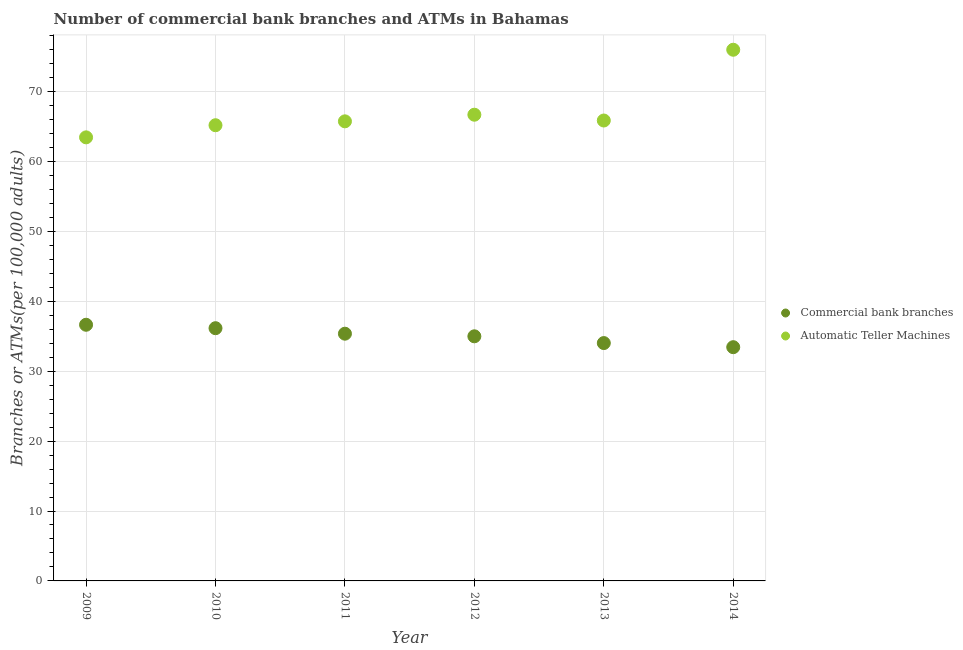How many different coloured dotlines are there?
Keep it short and to the point. 2. What is the number of atms in 2009?
Offer a terse response. 63.44. Across all years, what is the maximum number of commercal bank branches?
Provide a short and direct response. 36.64. Across all years, what is the minimum number of commercal bank branches?
Your answer should be very brief. 33.43. In which year was the number of atms minimum?
Ensure brevity in your answer.  2009. What is the total number of commercal bank branches in the graph?
Provide a short and direct response. 210.58. What is the difference between the number of atms in 2010 and that in 2013?
Your response must be concise. -0.67. What is the difference between the number of atms in 2010 and the number of commercal bank branches in 2012?
Offer a terse response. 30.19. What is the average number of commercal bank branches per year?
Make the answer very short. 35.1. In the year 2011, what is the difference between the number of atms and number of commercal bank branches?
Your response must be concise. 30.37. What is the ratio of the number of commercal bank branches in 2010 to that in 2014?
Offer a very short reply. 1.08. What is the difference between the highest and the second highest number of commercal bank branches?
Keep it short and to the point. 0.49. What is the difference between the highest and the lowest number of atms?
Your answer should be compact. 12.53. In how many years, is the number of commercal bank branches greater than the average number of commercal bank branches taken over all years?
Keep it short and to the point. 3. Is the sum of the number of atms in 2009 and 2011 greater than the maximum number of commercal bank branches across all years?
Your response must be concise. Yes. How many dotlines are there?
Ensure brevity in your answer.  2. Does the graph contain any zero values?
Provide a short and direct response. No. How many legend labels are there?
Offer a very short reply. 2. What is the title of the graph?
Keep it short and to the point. Number of commercial bank branches and ATMs in Bahamas. What is the label or title of the Y-axis?
Your response must be concise. Branches or ATMs(per 100,0 adults). What is the Branches or ATMs(per 100,000 adults) of Commercial bank branches in 2009?
Provide a short and direct response. 36.64. What is the Branches or ATMs(per 100,000 adults) of Automatic Teller Machines in 2009?
Your answer should be very brief. 63.44. What is the Branches or ATMs(per 100,000 adults) in Commercial bank branches in 2010?
Keep it short and to the point. 36.15. What is the Branches or ATMs(per 100,000 adults) in Automatic Teller Machines in 2010?
Your answer should be compact. 65.18. What is the Branches or ATMs(per 100,000 adults) of Commercial bank branches in 2011?
Keep it short and to the point. 35.36. What is the Branches or ATMs(per 100,000 adults) in Automatic Teller Machines in 2011?
Offer a very short reply. 65.73. What is the Branches or ATMs(per 100,000 adults) in Commercial bank branches in 2012?
Give a very brief answer. 34.99. What is the Branches or ATMs(per 100,000 adults) of Automatic Teller Machines in 2012?
Your response must be concise. 66.68. What is the Branches or ATMs(per 100,000 adults) in Commercial bank branches in 2013?
Your answer should be compact. 34.02. What is the Branches or ATMs(per 100,000 adults) in Automatic Teller Machines in 2013?
Provide a short and direct response. 65.85. What is the Branches or ATMs(per 100,000 adults) of Commercial bank branches in 2014?
Your answer should be compact. 33.43. What is the Branches or ATMs(per 100,000 adults) of Automatic Teller Machines in 2014?
Provide a succinct answer. 75.97. Across all years, what is the maximum Branches or ATMs(per 100,000 adults) in Commercial bank branches?
Offer a very short reply. 36.64. Across all years, what is the maximum Branches or ATMs(per 100,000 adults) in Automatic Teller Machines?
Give a very brief answer. 75.97. Across all years, what is the minimum Branches or ATMs(per 100,000 adults) of Commercial bank branches?
Give a very brief answer. 33.43. Across all years, what is the minimum Branches or ATMs(per 100,000 adults) of Automatic Teller Machines?
Make the answer very short. 63.44. What is the total Branches or ATMs(per 100,000 adults) in Commercial bank branches in the graph?
Your answer should be compact. 210.58. What is the total Branches or ATMs(per 100,000 adults) in Automatic Teller Machines in the graph?
Provide a succinct answer. 402.86. What is the difference between the Branches or ATMs(per 100,000 adults) in Commercial bank branches in 2009 and that in 2010?
Keep it short and to the point. 0.49. What is the difference between the Branches or ATMs(per 100,000 adults) in Automatic Teller Machines in 2009 and that in 2010?
Give a very brief answer. -1.73. What is the difference between the Branches or ATMs(per 100,000 adults) of Commercial bank branches in 2009 and that in 2011?
Ensure brevity in your answer.  1.28. What is the difference between the Branches or ATMs(per 100,000 adults) in Automatic Teller Machines in 2009 and that in 2011?
Offer a terse response. -2.29. What is the difference between the Branches or ATMs(per 100,000 adults) in Commercial bank branches in 2009 and that in 2012?
Your response must be concise. 1.65. What is the difference between the Branches or ATMs(per 100,000 adults) in Automatic Teller Machines in 2009 and that in 2012?
Offer a very short reply. -3.24. What is the difference between the Branches or ATMs(per 100,000 adults) in Commercial bank branches in 2009 and that in 2013?
Provide a succinct answer. 2.62. What is the difference between the Branches or ATMs(per 100,000 adults) of Automatic Teller Machines in 2009 and that in 2013?
Your response must be concise. -2.41. What is the difference between the Branches or ATMs(per 100,000 adults) of Commercial bank branches in 2009 and that in 2014?
Offer a very short reply. 3.21. What is the difference between the Branches or ATMs(per 100,000 adults) in Automatic Teller Machines in 2009 and that in 2014?
Provide a succinct answer. -12.53. What is the difference between the Branches or ATMs(per 100,000 adults) of Commercial bank branches in 2010 and that in 2011?
Offer a terse response. 0.79. What is the difference between the Branches or ATMs(per 100,000 adults) in Automatic Teller Machines in 2010 and that in 2011?
Your answer should be very brief. -0.56. What is the difference between the Branches or ATMs(per 100,000 adults) of Commercial bank branches in 2010 and that in 2012?
Provide a short and direct response. 1.16. What is the difference between the Branches or ATMs(per 100,000 adults) in Automatic Teller Machines in 2010 and that in 2012?
Your response must be concise. -1.5. What is the difference between the Branches or ATMs(per 100,000 adults) in Commercial bank branches in 2010 and that in 2013?
Your answer should be compact. 2.13. What is the difference between the Branches or ATMs(per 100,000 adults) of Automatic Teller Machines in 2010 and that in 2013?
Ensure brevity in your answer.  -0.67. What is the difference between the Branches or ATMs(per 100,000 adults) of Commercial bank branches in 2010 and that in 2014?
Provide a short and direct response. 2.71. What is the difference between the Branches or ATMs(per 100,000 adults) in Automatic Teller Machines in 2010 and that in 2014?
Your response must be concise. -10.8. What is the difference between the Branches or ATMs(per 100,000 adults) of Commercial bank branches in 2011 and that in 2012?
Your answer should be compact. 0.37. What is the difference between the Branches or ATMs(per 100,000 adults) in Automatic Teller Machines in 2011 and that in 2012?
Provide a succinct answer. -0.95. What is the difference between the Branches or ATMs(per 100,000 adults) in Commercial bank branches in 2011 and that in 2013?
Provide a short and direct response. 1.34. What is the difference between the Branches or ATMs(per 100,000 adults) of Automatic Teller Machines in 2011 and that in 2013?
Your answer should be very brief. -0.12. What is the difference between the Branches or ATMs(per 100,000 adults) in Commercial bank branches in 2011 and that in 2014?
Ensure brevity in your answer.  1.93. What is the difference between the Branches or ATMs(per 100,000 adults) in Automatic Teller Machines in 2011 and that in 2014?
Give a very brief answer. -10.24. What is the difference between the Branches or ATMs(per 100,000 adults) of Commercial bank branches in 2012 and that in 2013?
Your response must be concise. 0.97. What is the difference between the Branches or ATMs(per 100,000 adults) of Automatic Teller Machines in 2012 and that in 2013?
Provide a short and direct response. 0.83. What is the difference between the Branches or ATMs(per 100,000 adults) in Commercial bank branches in 2012 and that in 2014?
Keep it short and to the point. 1.56. What is the difference between the Branches or ATMs(per 100,000 adults) in Automatic Teller Machines in 2012 and that in 2014?
Keep it short and to the point. -9.29. What is the difference between the Branches or ATMs(per 100,000 adults) of Commercial bank branches in 2013 and that in 2014?
Your answer should be compact. 0.59. What is the difference between the Branches or ATMs(per 100,000 adults) of Automatic Teller Machines in 2013 and that in 2014?
Your answer should be very brief. -10.12. What is the difference between the Branches or ATMs(per 100,000 adults) in Commercial bank branches in 2009 and the Branches or ATMs(per 100,000 adults) in Automatic Teller Machines in 2010?
Ensure brevity in your answer.  -28.54. What is the difference between the Branches or ATMs(per 100,000 adults) in Commercial bank branches in 2009 and the Branches or ATMs(per 100,000 adults) in Automatic Teller Machines in 2011?
Offer a terse response. -29.1. What is the difference between the Branches or ATMs(per 100,000 adults) in Commercial bank branches in 2009 and the Branches or ATMs(per 100,000 adults) in Automatic Teller Machines in 2012?
Offer a terse response. -30.04. What is the difference between the Branches or ATMs(per 100,000 adults) in Commercial bank branches in 2009 and the Branches or ATMs(per 100,000 adults) in Automatic Teller Machines in 2013?
Offer a terse response. -29.21. What is the difference between the Branches or ATMs(per 100,000 adults) in Commercial bank branches in 2009 and the Branches or ATMs(per 100,000 adults) in Automatic Teller Machines in 2014?
Your answer should be compact. -39.34. What is the difference between the Branches or ATMs(per 100,000 adults) of Commercial bank branches in 2010 and the Branches or ATMs(per 100,000 adults) of Automatic Teller Machines in 2011?
Keep it short and to the point. -29.59. What is the difference between the Branches or ATMs(per 100,000 adults) of Commercial bank branches in 2010 and the Branches or ATMs(per 100,000 adults) of Automatic Teller Machines in 2012?
Offer a terse response. -30.53. What is the difference between the Branches or ATMs(per 100,000 adults) of Commercial bank branches in 2010 and the Branches or ATMs(per 100,000 adults) of Automatic Teller Machines in 2013?
Ensure brevity in your answer.  -29.7. What is the difference between the Branches or ATMs(per 100,000 adults) in Commercial bank branches in 2010 and the Branches or ATMs(per 100,000 adults) in Automatic Teller Machines in 2014?
Provide a succinct answer. -39.83. What is the difference between the Branches or ATMs(per 100,000 adults) of Commercial bank branches in 2011 and the Branches or ATMs(per 100,000 adults) of Automatic Teller Machines in 2012?
Provide a short and direct response. -31.32. What is the difference between the Branches or ATMs(per 100,000 adults) in Commercial bank branches in 2011 and the Branches or ATMs(per 100,000 adults) in Automatic Teller Machines in 2013?
Your answer should be very brief. -30.49. What is the difference between the Branches or ATMs(per 100,000 adults) of Commercial bank branches in 2011 and the Branches or ATMs(per 100,000 adults) of Automatic Teller Machines in 2014?
Your answer should be very brief. -40.61. What is the difference between the Branches or ATMs(per 100,000 adults) in Commercial bank branches in 2012 and the Branches or ATMs(per 100,000 adults) in Automatic Teller Machines in 2013?
Provide a succinct answer. -30.86. What is the difference between the Branches or ATMs(per 100,000 adults) in Commercial bank branches in 2012 and the Branches or ATMs(per 100,000 adults) in Automatic Teller Machines in 2014?
Your response must be concise. -40.99. What is the difference between the Branches or ATMs(per 100,000 adults) of Commercial bank branches in 2013 and the Branches or ATMs(per 100,000 adults) of Automatic Teller Machines in 2014?
Provide a short and direct response. -41.95. What is the average Branches or ATMs(per 100,000 adults) in Commercial bank branches per year?
Give a very brief answer. 35.1. What is the average Branches or ATMs(per 100,000 adults) in Automatic Teller Machines per year?
Give a very brief answer. 67.14. In the year 2009, what is the difference between the Branches or ATMs(per 100,000 adults) in Commercial bank branches and Branches or ATMs(per 100,000 adults) in Automatic Teller Machines?
Provide a short and direct response. -26.8. In the year 2010, what is the difference between the Branches or ATMs(per 100,000 adults) of Commercial bank branches and Branches or ATMs(per 100,000 adults) of Automatic Teller Machines?
Give a very brief answer. -29.03. In the year 2011, what is the difference between the Branches or ATMs(per 100,000 adults) in Commercial bank branches and Branches or ATMs(per 100,000 adults) in Automatic Teller Machines?
Provide a succinct answer. -30.37. In the year 2012, what is the difference between the Branches or ATMs(per 100,000 adults) of Commercial bank branches and Branches or ATMs(per 100,000 adults) of Automatic Teller Machines?
Provide a succinct answer. -31.69. In the year 2013, what is the difference between the Branches or ATMs(per 100,000 adults) of Commercial bank branches and Branches or ATMs(per 100,000 adults) of Automatic Teller Machines?
Keep it short and to the point. -31.83. In the year 2014, what is the difference between the Branches or ATMs(per 100,000 adults) of Commercial bank branches and Branches or ATMs(per 100,000 adults) of Automatic Teller Machines?
Offer a very short reply. -42.54. What is the ratio of the Branches or ATMs(per 100,000 adults) in Commercial bank branches in 2009 to that in 2010?
Your answer should be very brief. 1.01. What is the ratio of the Branches or ATMs(per 100,000 adults) of Automatic Teller Machines in 2009 to that in 2010?
Keep it short and to the point. 0.97. What is the ratio of the Branches or ATMs(per 100,000 adults) in Commercial bank branches in 2009 to that in 2011?
Your response must be concise. 1.04. What is the ratio of the Branches or ATMs(per 100,000 adults) in Automatic Teller Machines in 2009 to that in 2011?
Provide a succinct answer. 0.97. What is the ratio of the Branches or ATMs(per 100,000 adults) in Commercial bank branches in 2009 to that in 2012?
Keep it short and to the point. 1.05. What is the ratio of the Branches or ATMs(per 100,000 adults) of Automatic Teller Machines in 2009 to that in 2012?
Offer a very short reply. 0.95. What is the ratio of the Branches or ATMs(per 100,000 adults) in Commercial bank branches in 2009 to that in 2013?
Your answer should be compact. 1.08. What is the ratio of the Branches or ATMs(per 100,000 adults) in Automatic Teller Machines in 2009 to that in 2013?
Ensure brevity in your answer.  0.96. What is the ratio of the Branches or ATMs(per 100,000 adults) of Commercial bank branches in 2009 to that in 2014?
Offer a terse response. 1.1. What is the ratio of the Branches or ATMs(per 100,000 adults) of Automatic Teller Machines in 2009 to that in 2014?
Your answer should be compact. 0.84. What is the ratio of the Branches or ATMs(per 100,000 adults) of Commercial bank branches in 2010 to that in 2011?
Give a very brief answer. 1.02. What is the ratio of the Branches or ATMs(per 100,000 adults) of Automatic Teller Machines in 2010 to that in 2011?
Offer a very short reply. 0.99. What is the ratio of the Branches or ATMs(per 100,000 adults) of Commercial bank branches in 2010 to that in 2012?
Ensure brevity in your answer.  1.03. What is the ratio of the Branches or ATMs(per 100,000 adults) of Automatic Teller Machines in 2010 to that in 2012?
Your answer should be compact. 0.98. What is the ratio of the Branches or ATMs(per 100,000 adults) in Automatic Teller Machines in 2010 to that in 2013?
Give a very brief answer. 0.99. What is the ratio of the Branches or ATMs(per 100,000 adults) in Commercial bank branches in 2010 to that in 2014?
Offer a terse response. 1.08. What is the ratio of the Branches or ATMs(per 100,000 adults) in Automatic Teller Machines in 2010 to that in 2014?
Your answer should be compact. 0.86. What is the ratio of the Branches or ATMs(per 100,000 adults) of Commercial bank branches in 2011 to that in 2012?
Offer a very short reply. 1.01. What is the ratio of the Branches or ATMs(per 100,000 adults) of Automatic Teller Machines in 2011 to that in 2012?
Ensure brevity in your answer.  0.99. What is the ratio of the Branches or ATMs(per 100,000 adults) of Commercial bank branches in 2011 to that in 2013?
Provide a succinct answer. 1.04. What is the ratio of the Branches or ATMs(per 100,000 adults) in Commercial bank branches in 2011 to that in 2014?
Offer a very short reply. 1.06. What is the ratio of the Branches or ATMs(per 100,000 adults) of Automatic Teller Machines in 2011 to that in 2014?
Give a very brief answer. 0.87. What is the ratio of the Branches or ATMs(per 100,000 adults) of Commercial bank branches in 2012 to that in 2013?
Your response must be concise. 1.03. What is the ratio of the Branches or ATMs(per 100,000 adults) of Automatic Teller Machines in 2012 to that in 2013?
Provide a succinct answer. 1.01. What is the ratio of the Branches or ATMs(per 100,000 adults) in Commercial bank branches in 2012 to that in 2014?
Provide a succinct answer. 1.05. What is the ratio of the Branches or ATMs(per 100,000 adults) in Automatic Teller Machines in 2012 to that in 2014?
Your answer should be compact. 0.88. What is the ratio of the Branches or ATMs(per 100,000 adults) in Commercial bank branches in 2013 to that in 2014?
Make the answer very short. 1.02. What is the ratio of the Branches or ATMs(per 100,000 adults) in Automatic Teller Machines in 2013 to that in 2014?
Make the answer very short. 0.87. What is the difference between the highest and the second highest Branches or ATMs(per 100,000 adults) of Commercial bank branches?
Give a very brief answer. 0.49. What is the difference between the highest and the second highest Branches or ATMs(per 100,000 adults) of Automatic Teller Machines?
Make the answer very short. 9.29. What is the difference between the highest and the lowest Branches or ATMs(per 100,000 adults) of Commercial bank branches?
Give a very brief answer. 3.21. What is the difference between the highest and the lowest Branches or ATMs(per 100,000 adults) of Automatic Teller Machines?
Offer a very short reply. 12.53. 